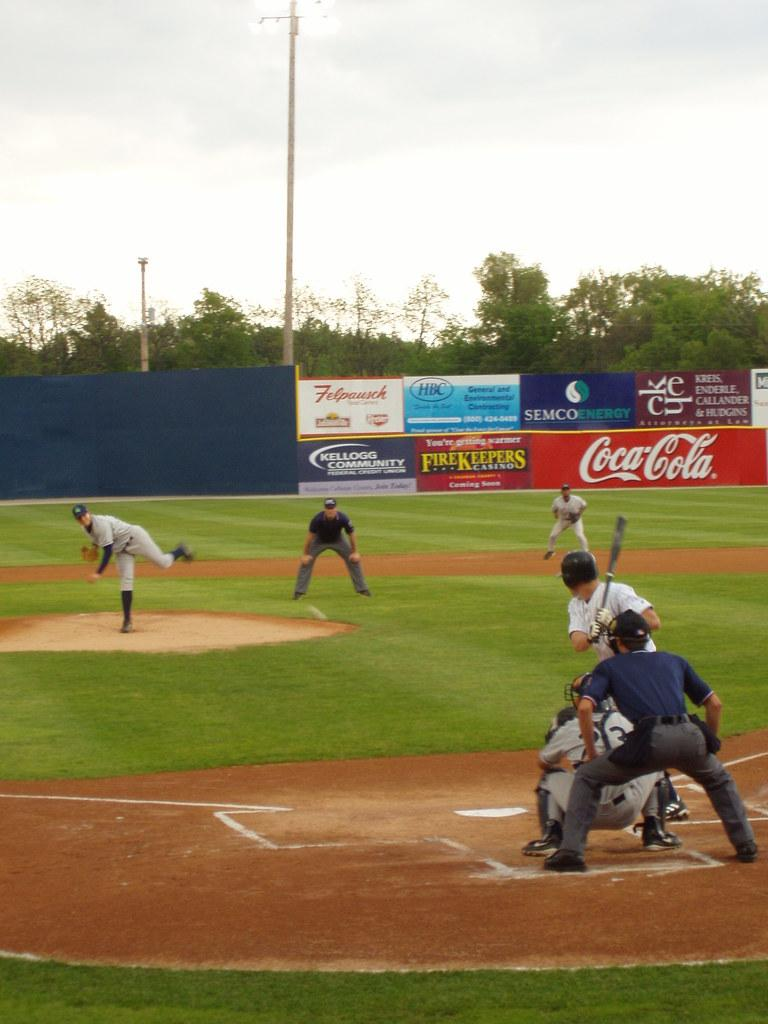<image>
Provide a brief description of the given image. Coca-cola is one of the brands advertised at this baseball field. 